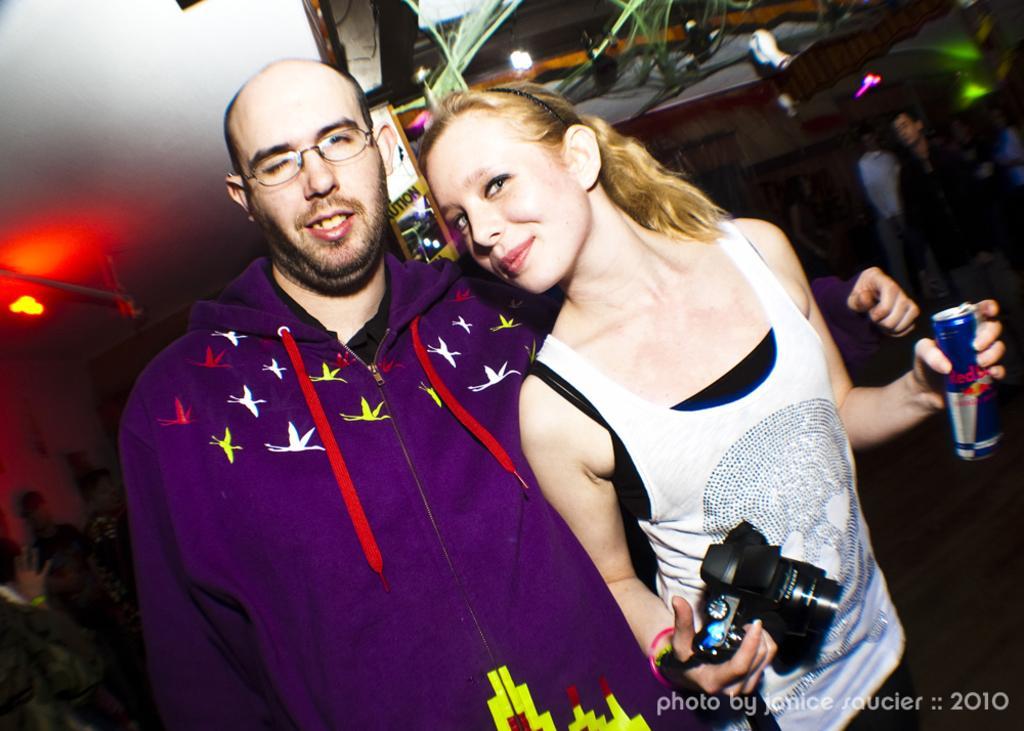Describe this image in one or two sentences. In this picture we can see a man and a woman are standing and smiling, a woman is holding a camera and a tin, in the background there are some people, on the left side there is a light, we can see some text at the right bottom, there is a board in the middle. 